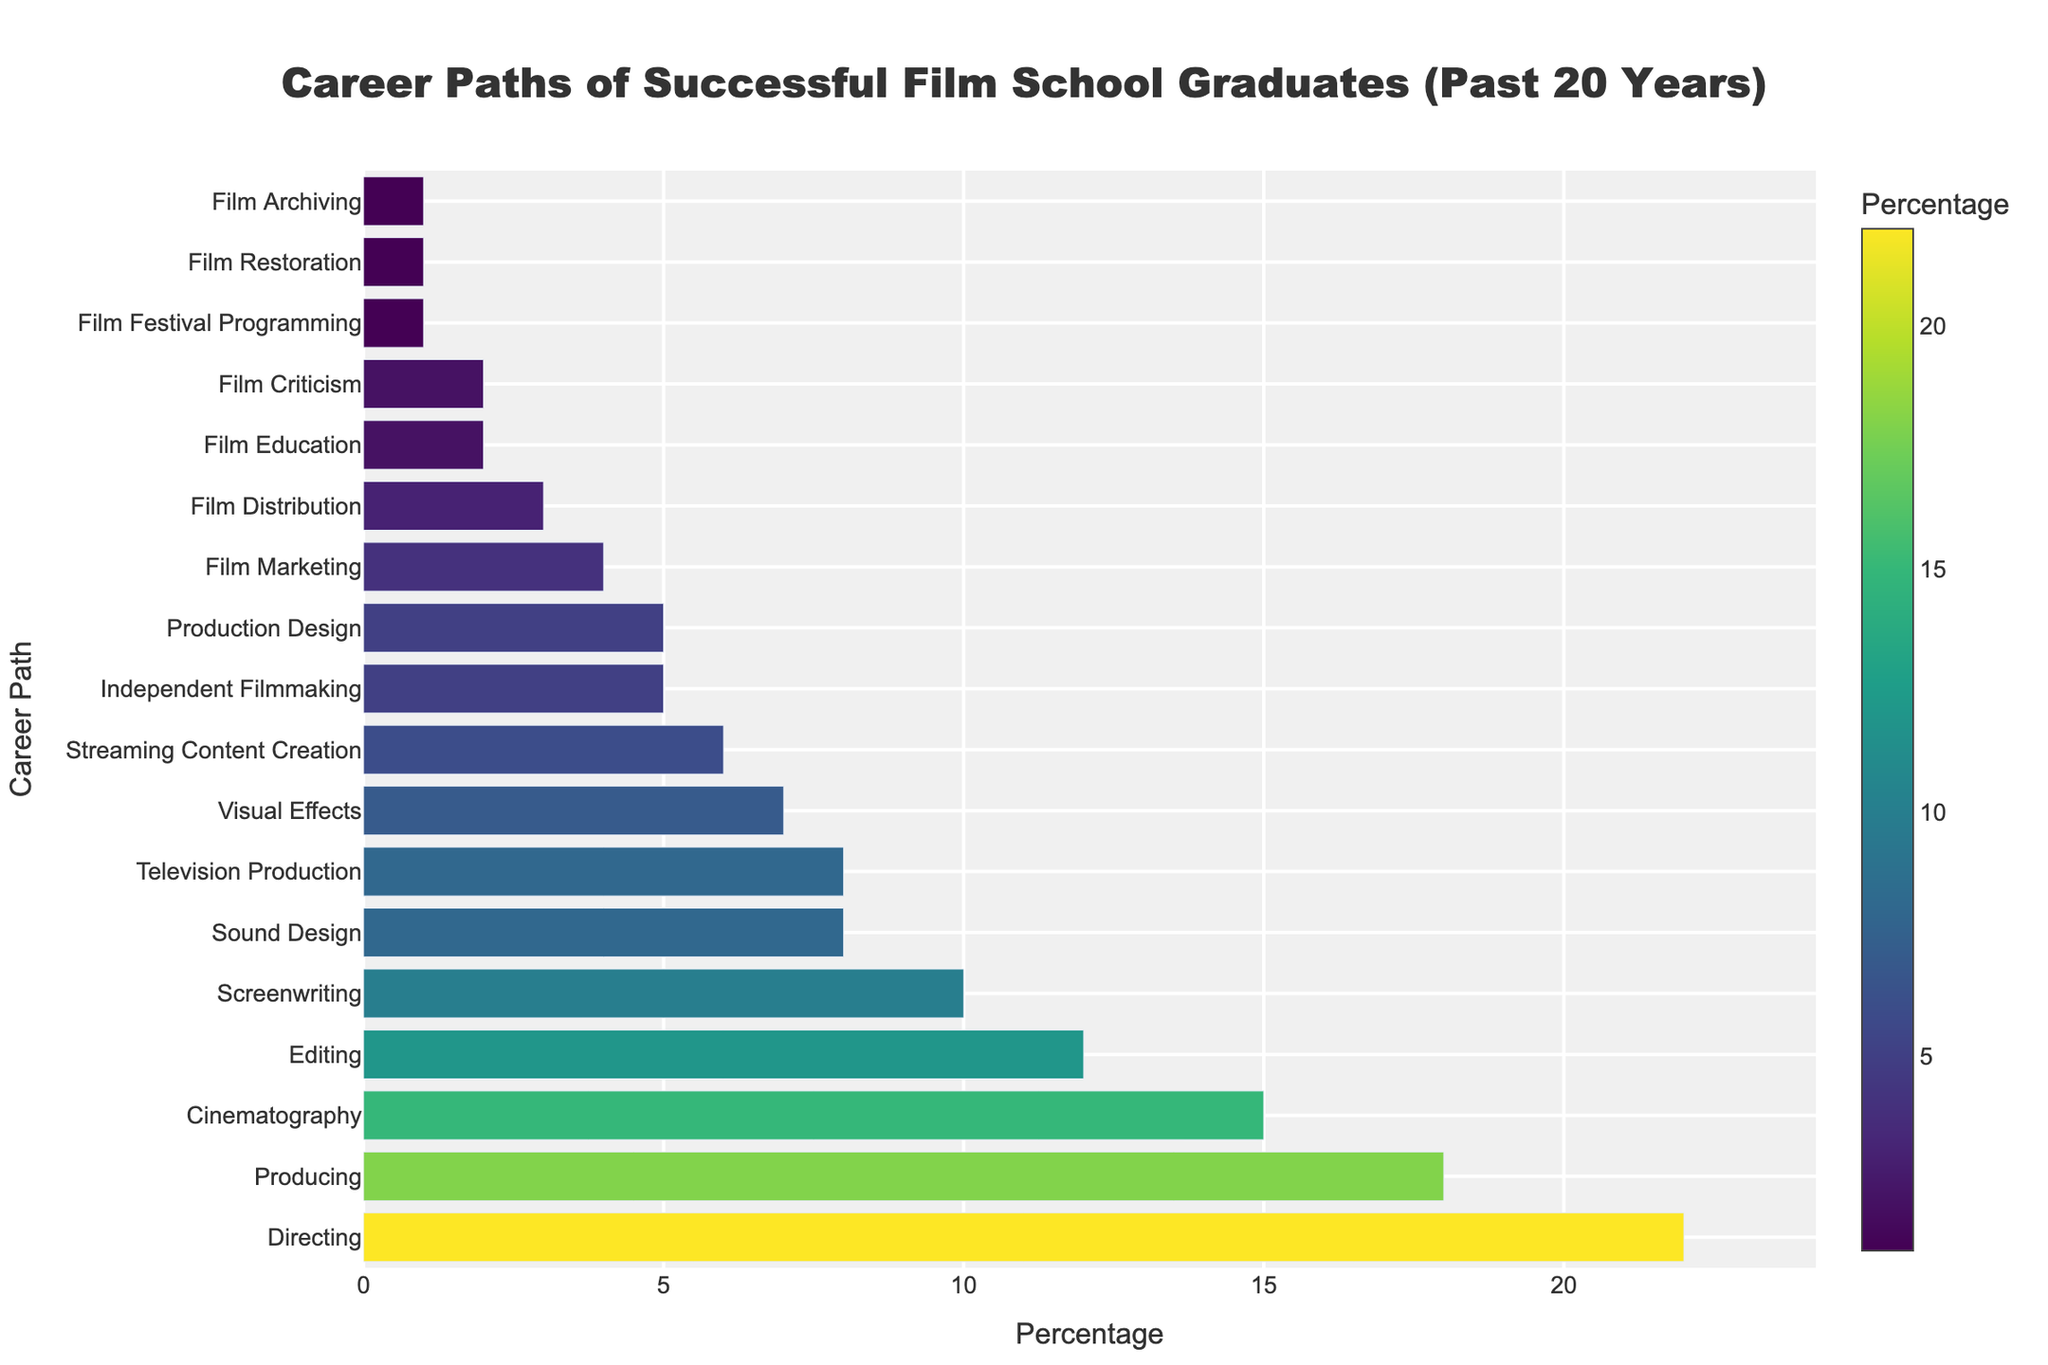Which career path has the highest percentage among successful film school graduates? The bar chart shows that the career path with the longest bar and highest value is "Directing" with 22%.
Answer: Directing Among editing, screenwriting, and sound design, which career path is most chosen by graduates? By looking at the lengths of the bars corresponding to Editing, Screenwriting, and Sound Design, Editing has a higher percentage (12%) compared to Screenwriting (10%) and Sound Design (8%).
Answer: Editing What is the combined percentage of graduates in Visual Effects and Production Design? The chart shows that the percentage for Visual Effects is 7% and for Production Design is 5%. Combining these, 7% + 5% = 12%.
Answer: 12% How does the percentage of graduates in Television Production compare to Streaming Content Creation? The chart shows that the bar for Television Production is at 8%, while the bar for Streaming Content Creation is at 6%. Therefore, Television Production has a higher percentage.
Answer: Television Production What is the total percentage of graduates pursuing Independent Filmmaking, Film Marketing, and Film Distribution? The chart shows Independent Filmmaking at 5%, Film Marketing at 4%, and Film Distribution at 3%. Summing these, 5% + 4% + 3% = 12%.
Answer: 12% Which career path has the lowest representation among graduates? The chart shows that Film Festival Programming, Film Restoration, and Film Archiving each have the smallest bars with 1%.
Answer: Film Festival Programming, Film Restoration, and Film Archiving How do the percentages for Cinematography and Directing compare? The bar for Directing shows 22% while Cinematography shows 15%. Therefore, Directing has a higher percentage.
Answer: Directing What is the median career path percentage for the career paths listed? To find the median value, we first list out all the percentages in ascending order: 1, 1, 1, 2, 2, 3, 4, 5, 5, 6, 7, 8, 8, 10, 12, 15, 18, 22. The middle value (9th and 10th) is at 5 and 6, so the median is (5+6)/2 = 5.5
Answer: 5.5 